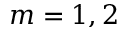<formula> <loc_0><loc_0><loc_500><loc_500>m = 1 , 2</formula> 